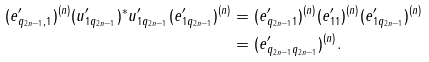Convert formula to latex. <formula><loc_0><loc_0><loc_500><loc_500>( e ^ { \prime } _ { q _ { 2 n - 1 } , 1 } ) ^ { ( n ) } ( u ^ { \prime } _ { 1 q _ { 2 n - 1 } } ) ^ { * } u ^ { \prime } _ { 1 q _ { 2 n - 1 } } ( e ^ { \prime } _ { 1 q _ { 2 n - 1 } } ) ^ { ( n ) } & = ( e ^ { \prime } _ { q _ { 2 n - 1 } 1 } ) ^ { ( n ) } ( e ^ { \prime } _ { 1 1 } ) ^ { ( n ) } ( e ^ { \prime } _ { 1 q _ { 2 n - 1 } } ) ^ { ( n ) } \\ & = ( e ^ { \prime } _ { q _ { 2 n - 1 } q _ { 2 n - 1 } } ) ^ { ( n ) } .</formula> 